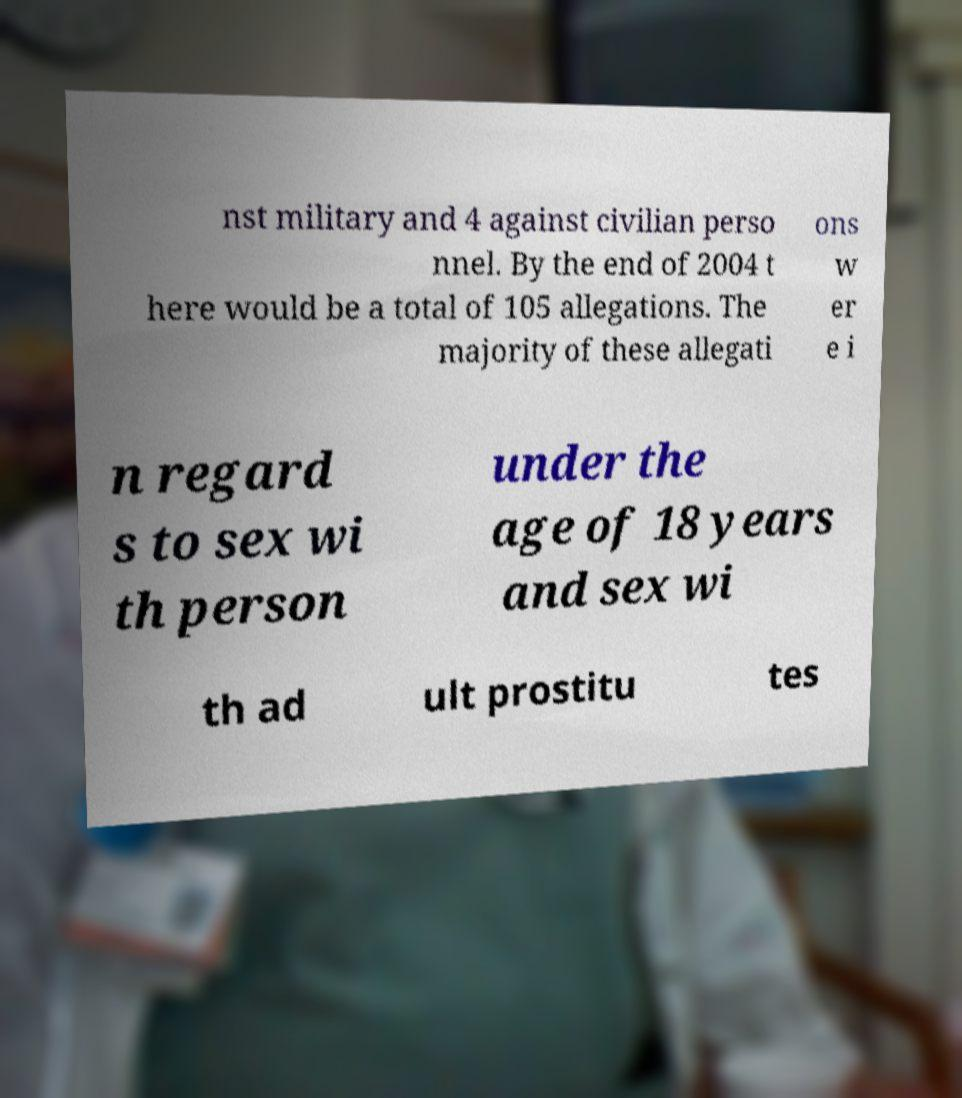Please identify and transcribe the text found in this image. nst military and 4 against civilian perso nnel. By the end of 2004 t here would be a total of 105 allegations. The majority of these allegati ons w er e i n regard s to sex wi th person under the age of 18 years and sex wi th ad ult prostitu tes 